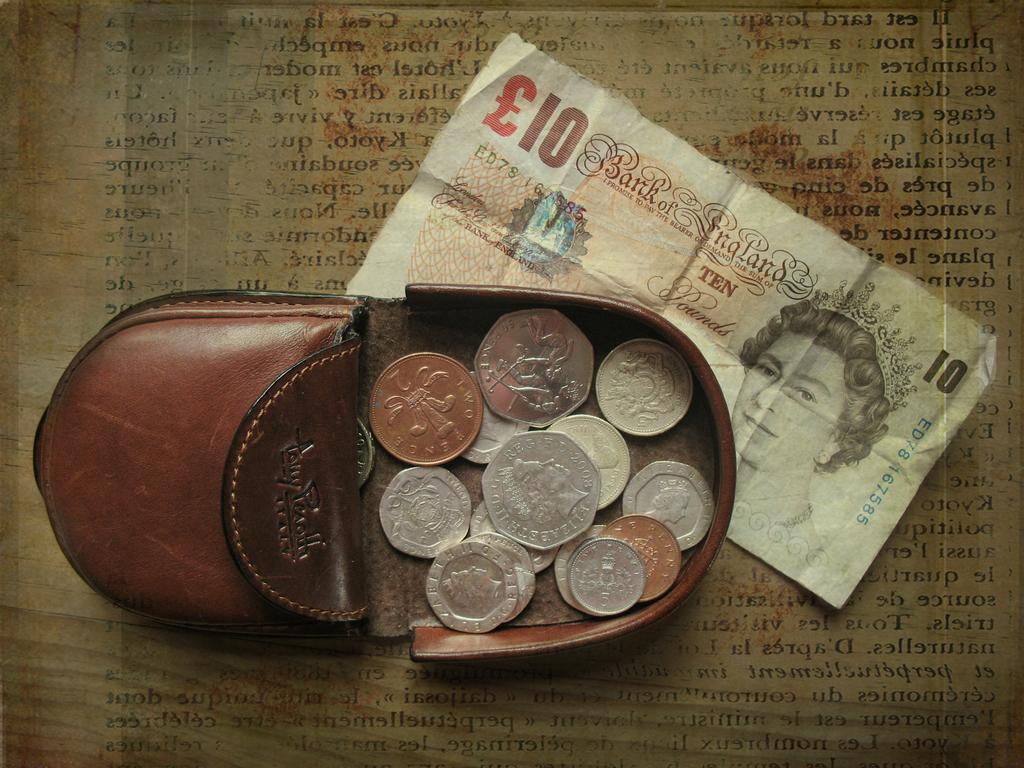<image>
Relay a brief, clear account of the picture shown. a 10 Bank of England note is under some coins 